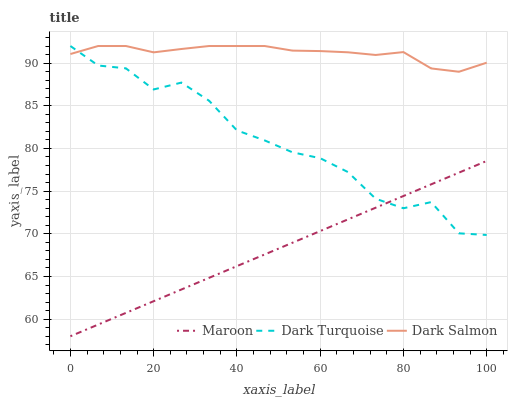Does Dark Salmon have the minimum area under the curve?
Answer yes or no. No. Does Maroon have the maximum area under the curve?
Answer yes or no. No. Is Dark Salmon the smoothest?
Answer yes or no. No. Is Dark Salmon the roughest?
Answer yes or no. No. Does Dark Salmon have the lowest value?
Answer yes or no. No. Does Maroon have the highest value?
Answer yes or no. No. Is Maroon less than Dark Salmon?
Answer yes or no. Yes. Is Dark Salmon greater than Maroon?
Answer yes or no. Yes. Does Maroon intersect Dark Salmon?
Answer yes or no. No. 